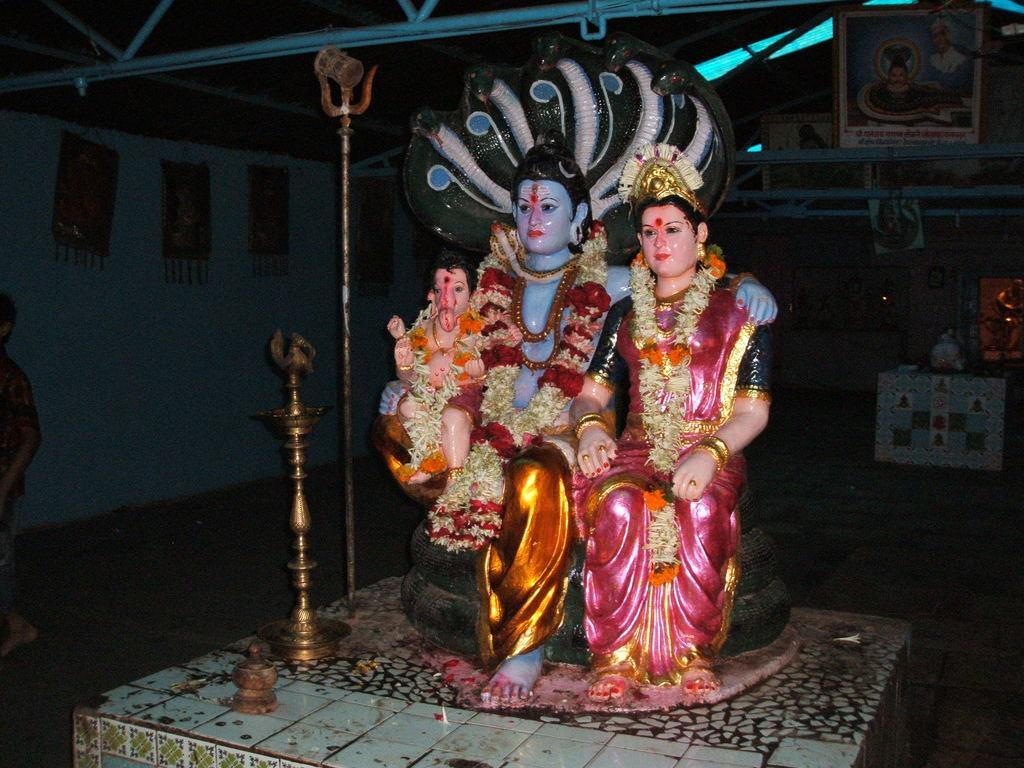In one or two sentences, can you explain what this image depicts? In this image, we can see some idols of gods on the surface. We can also see a lamp, metal pole and an object. We can see the ground with an object. We can see some frames and the shed. We can see the wall with some posters. We can also see a person on the left. 